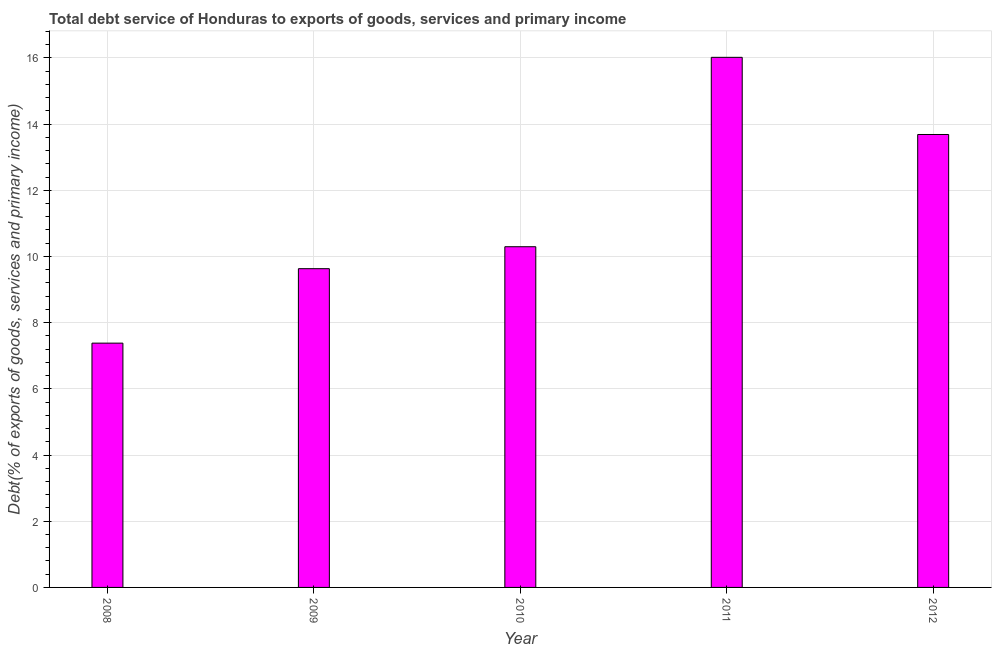What is the title of the graph?
Ensure brevity in your answer.  Total debt service of Honduras to exports of goods, services and primary income. What is the label or title of the Y-axis?
Your answer should be compact. Debt(% of exports of goods, services and primary income). What is the total debt service in 2011?
Offer a very short reply. 16.02. Across all years, what is the maximum total debt service?
Your response must be concise. 16.02. Across all years, what is the minimum total debt service?
Keep it short and to the point. 7.38. In which year was the total debt service maximum?
Your response must be concise. 2011. In which year was the total debt service minimum?
Offer a very short reply. 2008. What is the sum of the total debt service?
Ensure brevity in your answer.  57.01. What is the difference between the total debt service in 2008 and 2012?
Ensure brevity in your answer.  -6.3. What is the average total debt service per year?
Make the answer very short. 11.4. What is the median total debt service?
Keep it short and to the point. 10.29. What is the ratio of the total debt service in 2009 to that in 2011?
Provide a short and direct response. 0.6. Is the total debt service in 2008 less than that in 2011?
Ensure brevity in your answer.  Yes. Is the difference between the total debt service in 2008 and 2011 greater than the difference between any two years?
Give a very brief answer. Yes. What is the difference between the highest and the second highest total debt service?
Make the answer very short. 2.33. Is the sum of the total debt service in 2009 and 2011 greater than the maximum total debt service across all years?
Offer a very short reply. Yes. What is the difference between the highest and the lowest total debt service?
Offer a terse response. 8.63. In how many years, is the total debt service greater than the average total debt service taken over all years?
Provide a succinct answer. 2. Are all the bars in the graph horizontal?
Your answer should be very brief. No. What is the difference between two consecutive major ticks on the Y-axis?
Offer a very short reply. 2. What is the Debt(% of exports of goods, services and primary income) in 2008?
Your answer should be compact. 7.38. What is the Debt(% of exports of goods, services and primary income) of 2009?
Keep it short and to the point. 9.63. What is the Debt(% of exports of goods, services and primary income) in 2010?
Offer a very short reply. 10.29. What is the Debt(% of exports of goods, services and primary income) in 2011?
Offer a terse response. 16.02. What is the Debt(% of exports of goods, services and primary income) of 2012?
Ensure brevity in your answer.  13.68. What is the difference between the Debt(% of exports of goods, services and primary income) in 2008 and 2009?
Provide a succinct answer. -2.25. What is the difference between the Debt(% of exports of goods, services and primary income) in 2008 and 2010?
Provide a short and direct response. -2.91. What is the difference between the Debt(% of exports of goods, services and primary income) in 2008 and 2011?
Your answer should be very brief. -8.63. What is the difference between the Debt(% of exports of goods, services and primary income) in 2008 and 2012?
Make the answer very short. -6.3. What is the difference between the Debt(% of exports of goods, services and primary income) in 2009 and 2010?
Give a very brief answer. -0.66. What is the difference between the Debt(% of exports of goods, services and primary income) in 2009 and 2011?
Offer a very short reply. -6.39. What is the difference between the Debt(% of exports of goods, services and primary income) in 2009 and 2012?
Your answer should be compact. -4.05. What is the difference between the Debt(% of exports of goods, services and primary income) in 2010 and 2011?
Provide a succinct answer. -5.72. What is the difference between the Debt(% of exports of goods, services and primary income) in 2010 and 2012?
Your answer should be compact. -3.39. What is the difference between the Debt(% of exports of goods, services and primary income) in 2011 and 2012?
Keep it short and to the point. 2.33. What is the ratio of the Debt(% of exports of goods, services and primary income) in 2008 to that in 2009?
Your response must be concise. 0.77. What is the ratio of the Debt(% of exports of goods, services and primary income) in 2008 to that in 2010?
Give a very brief answer. 0.72. What is the ratio of the Debt(% of exports of goods, services and primary income) in 2008 to that in 2011?
Make the answer very short. 0.46. What is the ratio of the Debt(% of exports of goods, services and primary income) in 2008 to that in 2012?
Offer a very short reply. 0.54. What is the ratio of the Debt(% of exports of goods, services and primary income) in 2009 to that in 2010?
Provide a succinct answer. 0.94. What is the ratio of the Debt(% of exports of goods, services and primary income) in 2009 to that in 2011?
Provide a succinct answer. 0.6. What is the ratio of the Debt(% of exports of goods, services and primary income) in 2009 to that in 2012?
Ensure brevity in your answer.  0.7. What is the ratio of the Debt(% of exports of goods, services and primary income) in 2010 to that in 2011?
Provide a short and direct response. 0.64. What is the ratio of the Debt(% of exports of goods, services and primary income) in 2010 to that in 2012?
Keep it short and to the point. 0.75. What is the ratio of the Debt(% of exports of goods, services and primary income) in 2011 to that in 2012?
Your answer should be very brief. 1.17. 